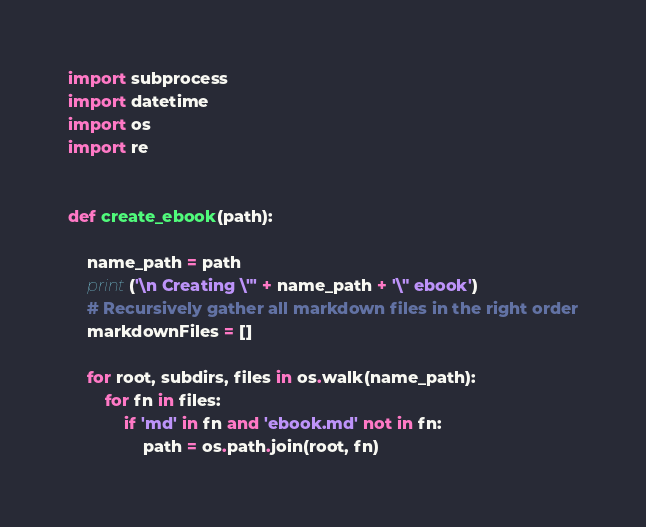<code> <loc_0><loc_0><loc_500><loc_500><_Python_>import subprocess
import datetime
import os
import re


def create_ebook(path):

    name_path = path
    print('\n Creating \"' + name_path + '\" ebook')
    # Recursively gather all markdown files in the right order
    markdownFiles = []

    for root, subdirs, files in os.walk(name_path):
        for fn in files:
            if 'md' in fn and 'ebook.md' not in fn:
                path = os.path.join(root, fn)
</code> 